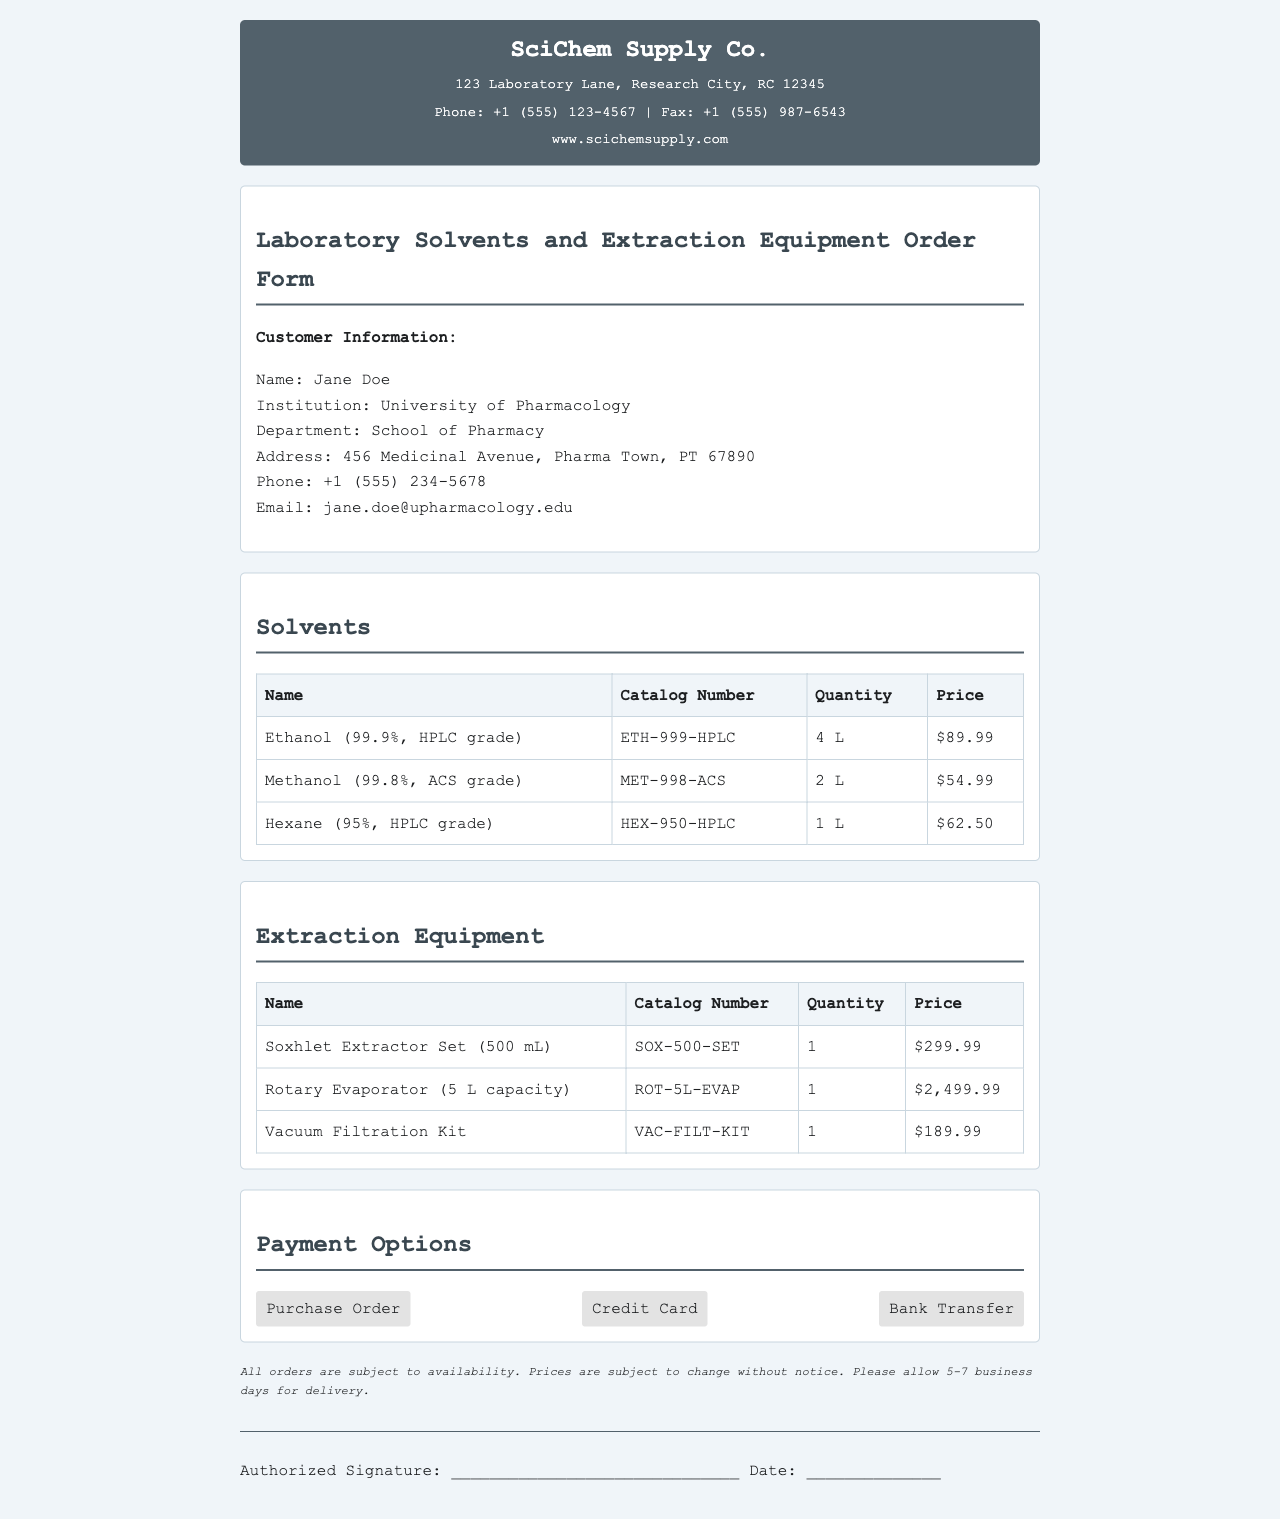What is the name of the scientific supply company? The name of the scientific supply company is at the top of the document in the header section.
Answer: SciChem Supply Co Who is the customer? The customer's name is presented in the customer information section of the document.
Answer: Jane Doe How many liters of Ethanol are ordered? The quantity of Ethanol is stated in the solvents section of the document.
Answer: 4 L What is the price of the Rotary Evaporator? The price of the Rotary Evaporator can be found in the extraction equipment table in the document.
Answer: $2,499.99 What payment options are listed? The payment options are outlined in the payment options section of the document.
Answer: Purchase Order, Credit Card, Bank Transfer How long should delivery take? The expected delivery time is mentioned in the terms section of the document.
Answer: 5-7 business days What is the catalog number for Methanol? The catalog number for Methanol is indicated in the solvents table within the document.
Answer: MET-998-ACS What is the total quantity of extraction equipment ordered? The extraction equipment ordered consists of three items, thus the total quantity is the sum of these items.
Answer: 3 